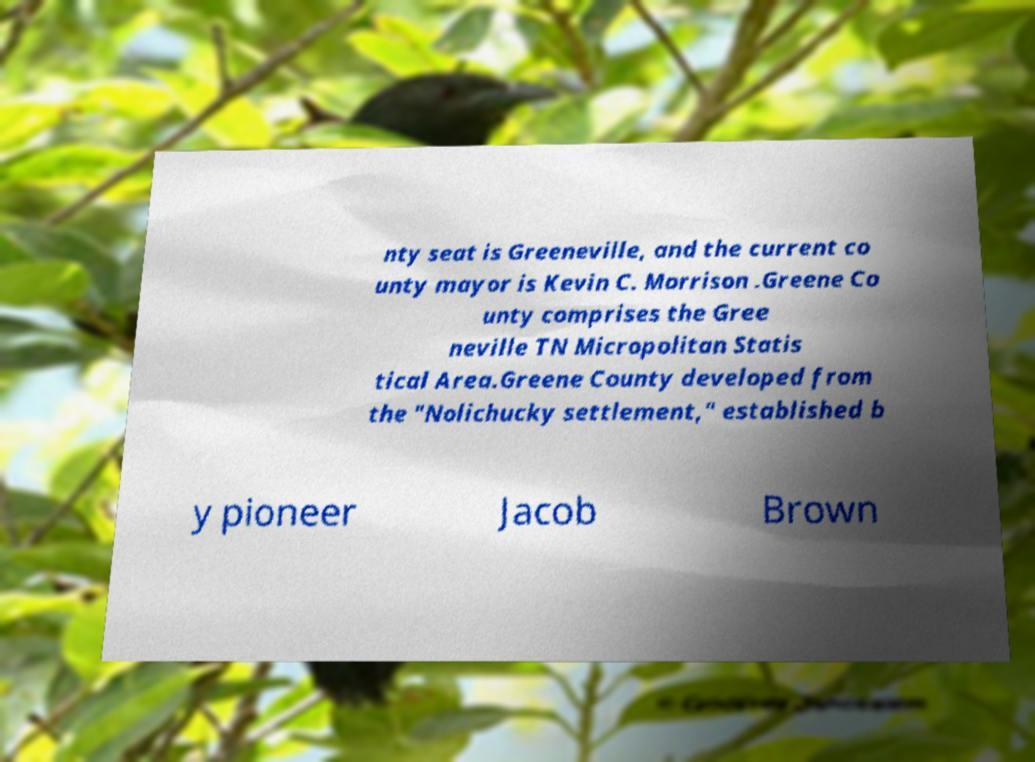Please read and relay the text visible in this image. What does it say? nty seat is Greeneville, and the current co unty mayor is Kevin C. Morrison .Greene Co unty comprises the Gree neville TN Micropolitan Statis tical Area.Greene County developed from the "Nolichucky settlement," established b y pioneer Jacob Brown 